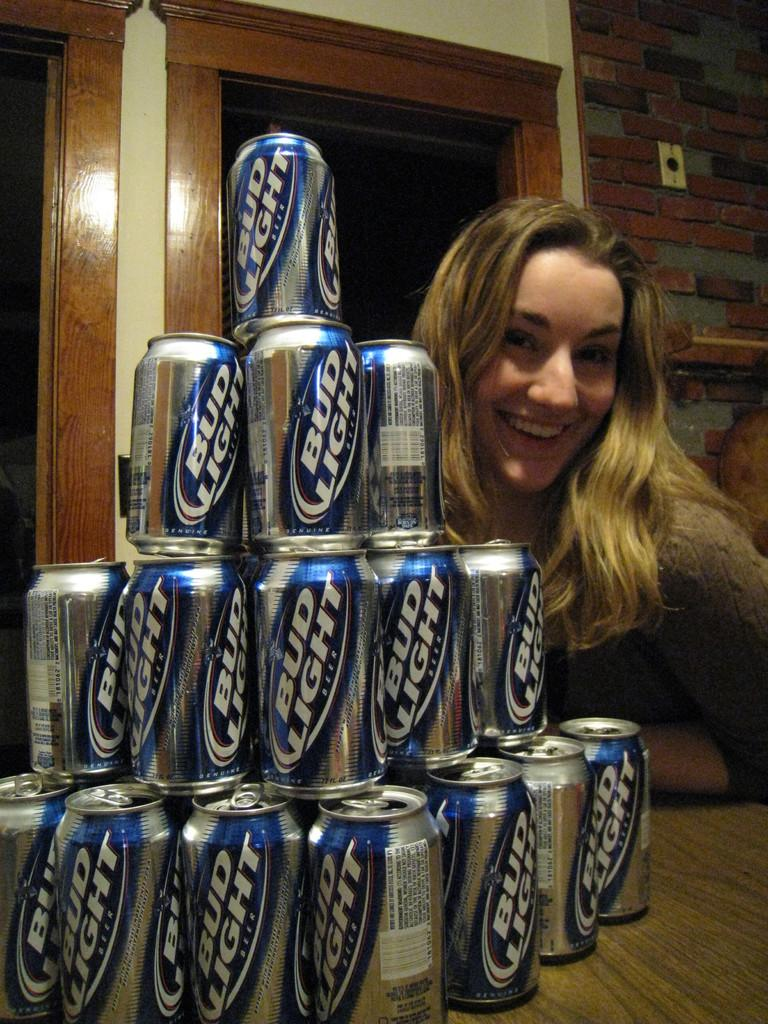Provide a one-sentence caption for the provided image. Bud light beer cans stacked in a display beside a smiling model. 